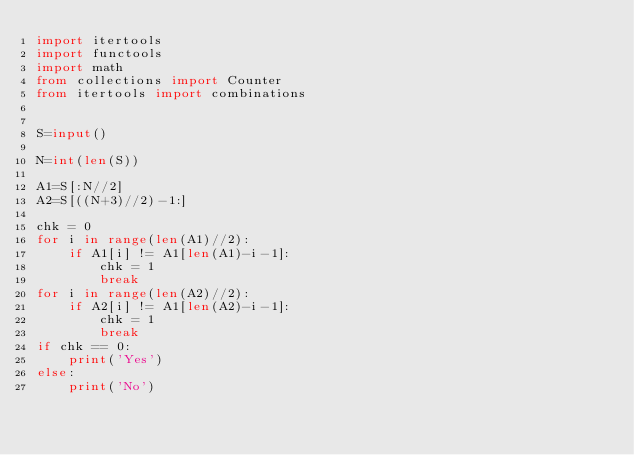<code> <loc_0><loc_0><loc_500><loc_500><_Python_>import itertools
import functools
import math
from collections import Counter
from itertools import combinations


S=input()

N=int(len(S))

A1=S[:N//2]
A2=S[((N+3)//2)-1:]

chk = 0
for i in range(len(A1)//2):
    if A1[i] != A1[len(A1)-i-1]:
        chk = 1
        break
for i in range(len(A2)//2):
    if A2[i] != A1[len(A2)-i-1]:
        chk = 1
        break
if chk == 0:
    print('Yes')
else:
    print('No')
</code> 